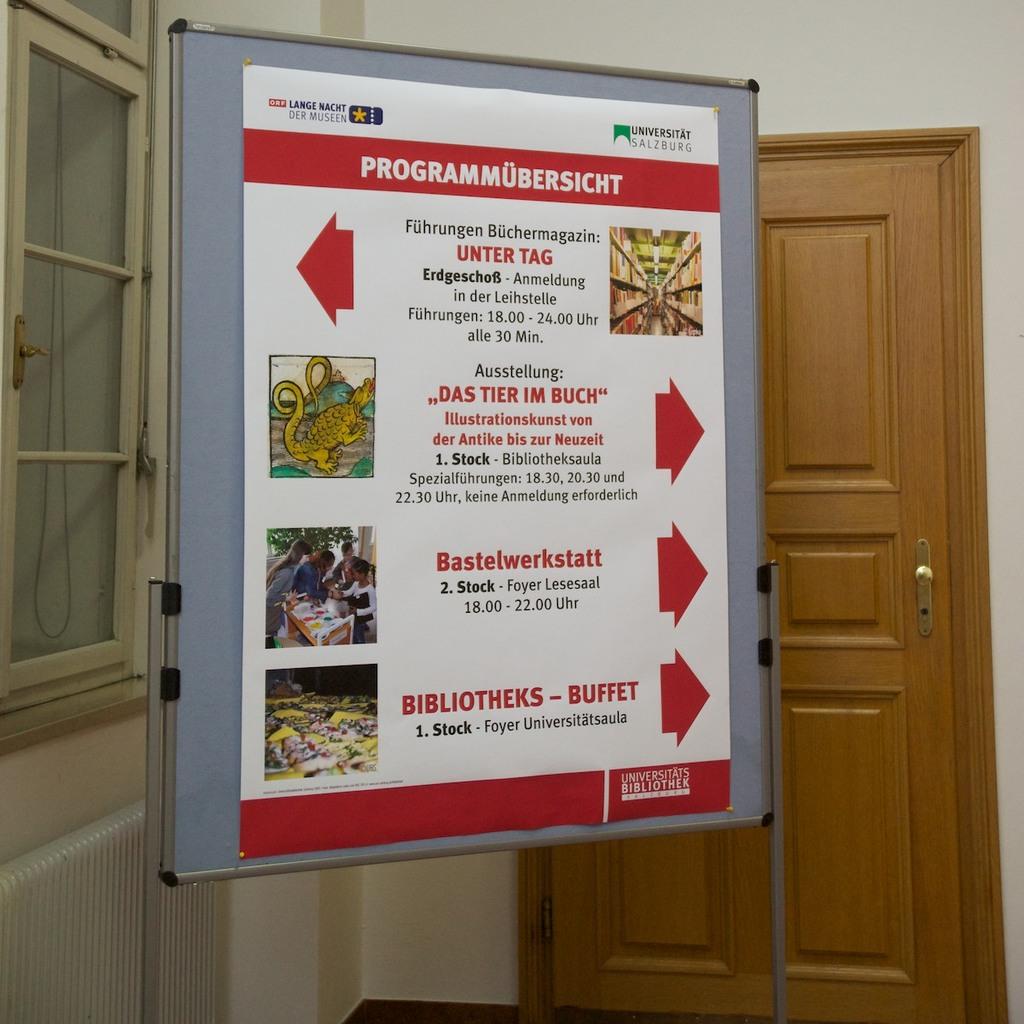What will a person encounter if they go to the left?
Your answer should be very brief. Unter tag. What are the big white words in the top of this board?
Your answer should be compact. Programmubersicht. 